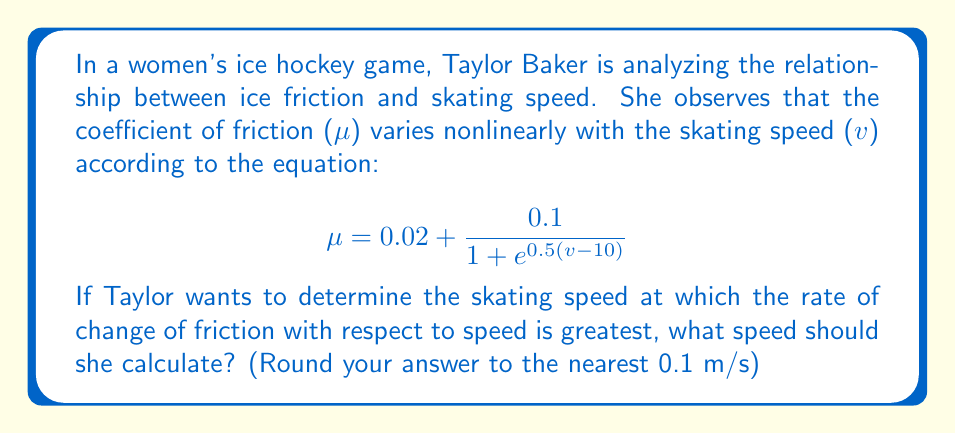Help me with this question. To solve this problem, we need to follow these steps:

1) The rate of change of friction with respect to speed is given by the derivative of $\mu$ with respect to $v$. Let's call this $\frac{d\mu}{dv}$.

2) We need to find $\frac{d\mu}{dv}$ using the chain rule:

   $$\frac{d\mu}{dv} = \frac{d}{dv}\left(0.02 + \frac{0.1}{1 + e^{0.5(v-10)}}\right)$$
   
   $$= \frac{-0.1 \cdot 0.5e^{0.5(v-10)}}{(1 + e^{0.5(v-10)})^2}$$

3) The speed at which $\frac{d\mu}{dv}$ is greatest will be where the second derivative $\frac{d^2\mu}{dv^2}$ equals zero.

4) However, finding $\frac{d^2\mu}{dv^2}$ and solving $\frac{d^2\mu}{dv^2} = 0$ algebraically is complex. Instead, we can observe that the function $\frac{0.1}{1 + e^{0.5(v-10)}}$ is a logistic function, which is symmetrical around its midpoint.

5) The midpoint of a logistic function occurs where the exponent in the denominator equals zero:

   $$0.5(v-10) = 0$$
   $$v-10 = 0$$
   $$v = 10$$

6) At this midpoint, the rate of change is greatest.

Therefore, the skating speed at which the rate of change of friction with respect to speed is greatest is 10 m/s.
Answer: 10.0 m/s 